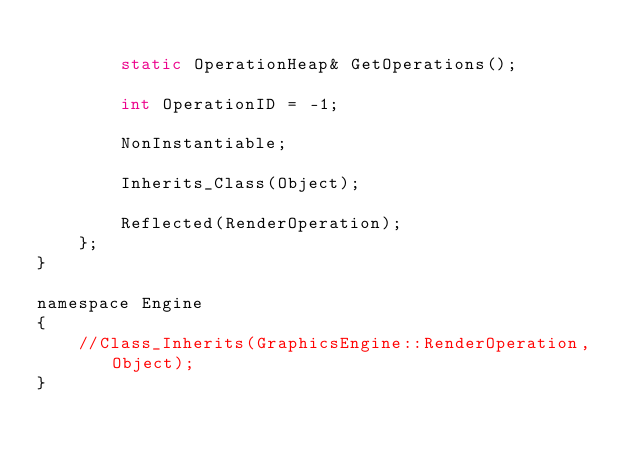<code> <loc_0><loc_0><loc_500><loc_500><_C_>
		static OperationHeap& GetOperations();

		int OperationID = -1;

		NonInstantiable;

		Inherits_Class(Object);

		Reflected(RenderOperation);
	};
}

namespace Engine
{
	//Class_Inherits(GraphicsEngine::RenderOperation, Object);
}</code> 